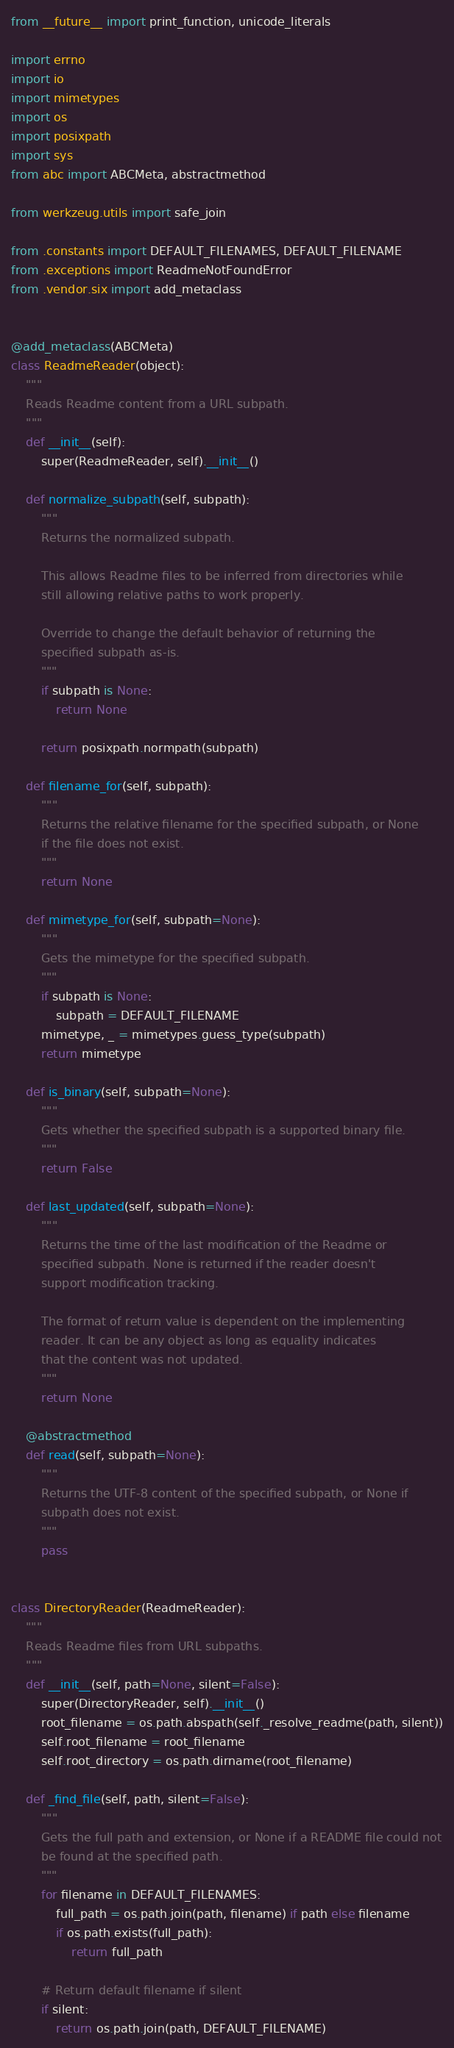<code> <loc_0><loc_0><loc_500><loc_500><_Python_>from __future__ import print_function, unicode_literals

import errno
import io
import mimetypes
import os
import posixpath
import sys
from abc import ABCMeta, abstractmethod

from werkzeug.utils import safe_join

from .constants import DEFAULT_FILENAMES, DEFAULT_FILENAME
from .exceptions import ReadmeNotFoundError
from .vendor.six import add_metaclass


@add_metaclass(ABCMeta)
class ReadmeReader(object):
    """
    Reads Readme content from a URL subpath.
    """
    def __init__(self):
        super(ReadmeReader, self).__init__()

    def normalize_subpath(self, subpath):
        """
        Returns the normalized subpath.

        This allows Readme files to be inferred from directories while
        still allowing relative paths to work properly.

        Override to change the default behavior of returning the
        specified subpath as-is.
        """
        if subpath is None:
            return None

        return posixpath.normpath(subpath)

    def filename_for(self, subpath):
        """
        Returns the relative filename for the specified subpath, or None
        if the file does not exist.
        """
        return None

    def mimetype_for(self, subpath=None):
        """
        Gets the mimetype for the specified subpath.
        """
        if subpath is None:
            subpath = DEFAULT_FILENAME
        mimetype, _ = mimetypes.guess_type(subpath)
        return mimetype

    def is_binary(self, subpath=None):
        """
        Gets whether the specified subpath is a supported binary file.
        """
        return False

    def last_updated(self, subpath=None):
        """
        Returns the time of the last modification of the Readme or
        specified subpath. None is returned if the reader doesn't
        support modification tracking.

        The format of return value is dependent on the implementing
        reader. It can be any object as long as equality indicates
        that the content was not updated.
        """
        return None

    @abstractmethod
    def read(self, subpath=None):
        """
        Returns the UTF-8 content of the specified subpath, or None if
        subpath does not exist.
        """
        pass


class DirectoryReader(ReadmeReader):
    """
    Reads Readme files from URL subpaths.
    """
    def __init__(self, path=None, silent=False):
        super(DirectoryReader, self).__init__()
        root_filename = os.path.abspath(self._resolve_readme(path, silent))
        self.root_filename = root_filename
        self.root_directory = os.path.dirname(root_filename)

    def _find_file(self, path, silent=False):
        """
        Gets the full path and extension, or None if a README file could not
        be found at the specified path.
        """
        for filename in DEFAULT_FILENAMES:
            full_path = os.path.join(path, filename) if path else filename
            if os.path.exists(full_path):
                return full_path

        # Return default filename if silent
        if silent:
            return os.path.join(path, DEFAULT_FILENAME)
</code> 